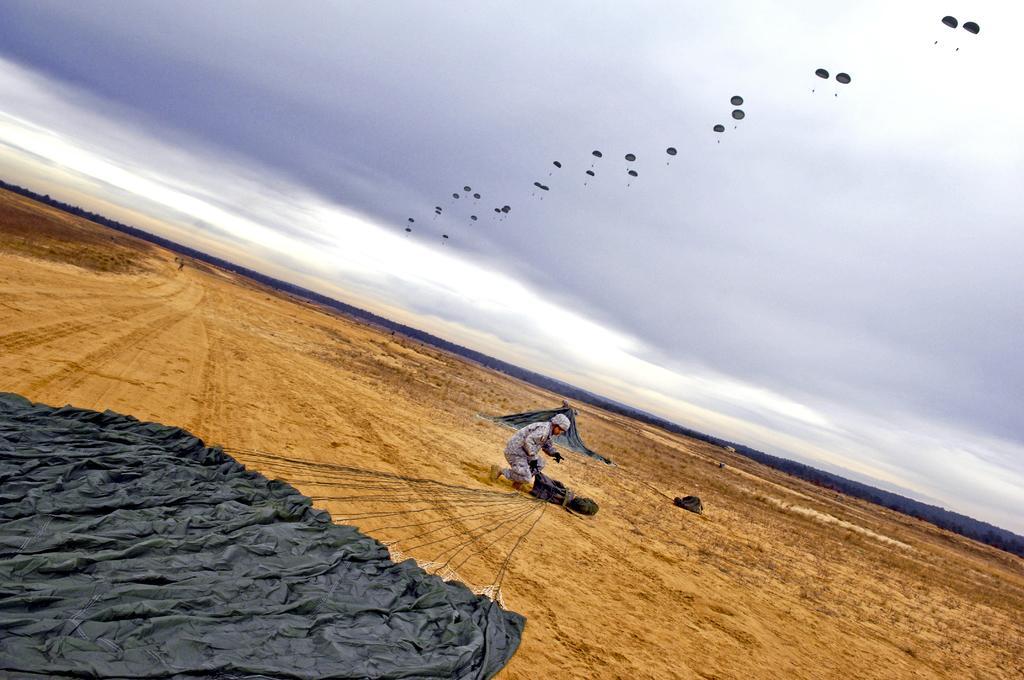Please provide a concise description of this image. This image is taken outdoors. At the top of the image there is a sky with clouds and there are a few parachutes. At the bottom of the image there is a ground and there is a parachute on the ground. In the middle of the image there is a man. 